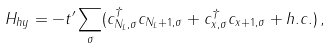<formula> <loc_0><loc_0><loc_500><loc_500>H _ { h y } = - t ^ { \prime } \sum _ { \sigma } ( c _ { N _ { L } , \sigma } ^ { \dagger } c _ { N _ { L } + 1 , \sigma } + c _ { x , \sigma } ^ { \dagger } c _ { x + 1 , \sigma } + h . c . ) \, ,</formula> 